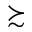<formula> <loc_0><loc_0><loc_500><loc_500>\succ s i m</formula> 